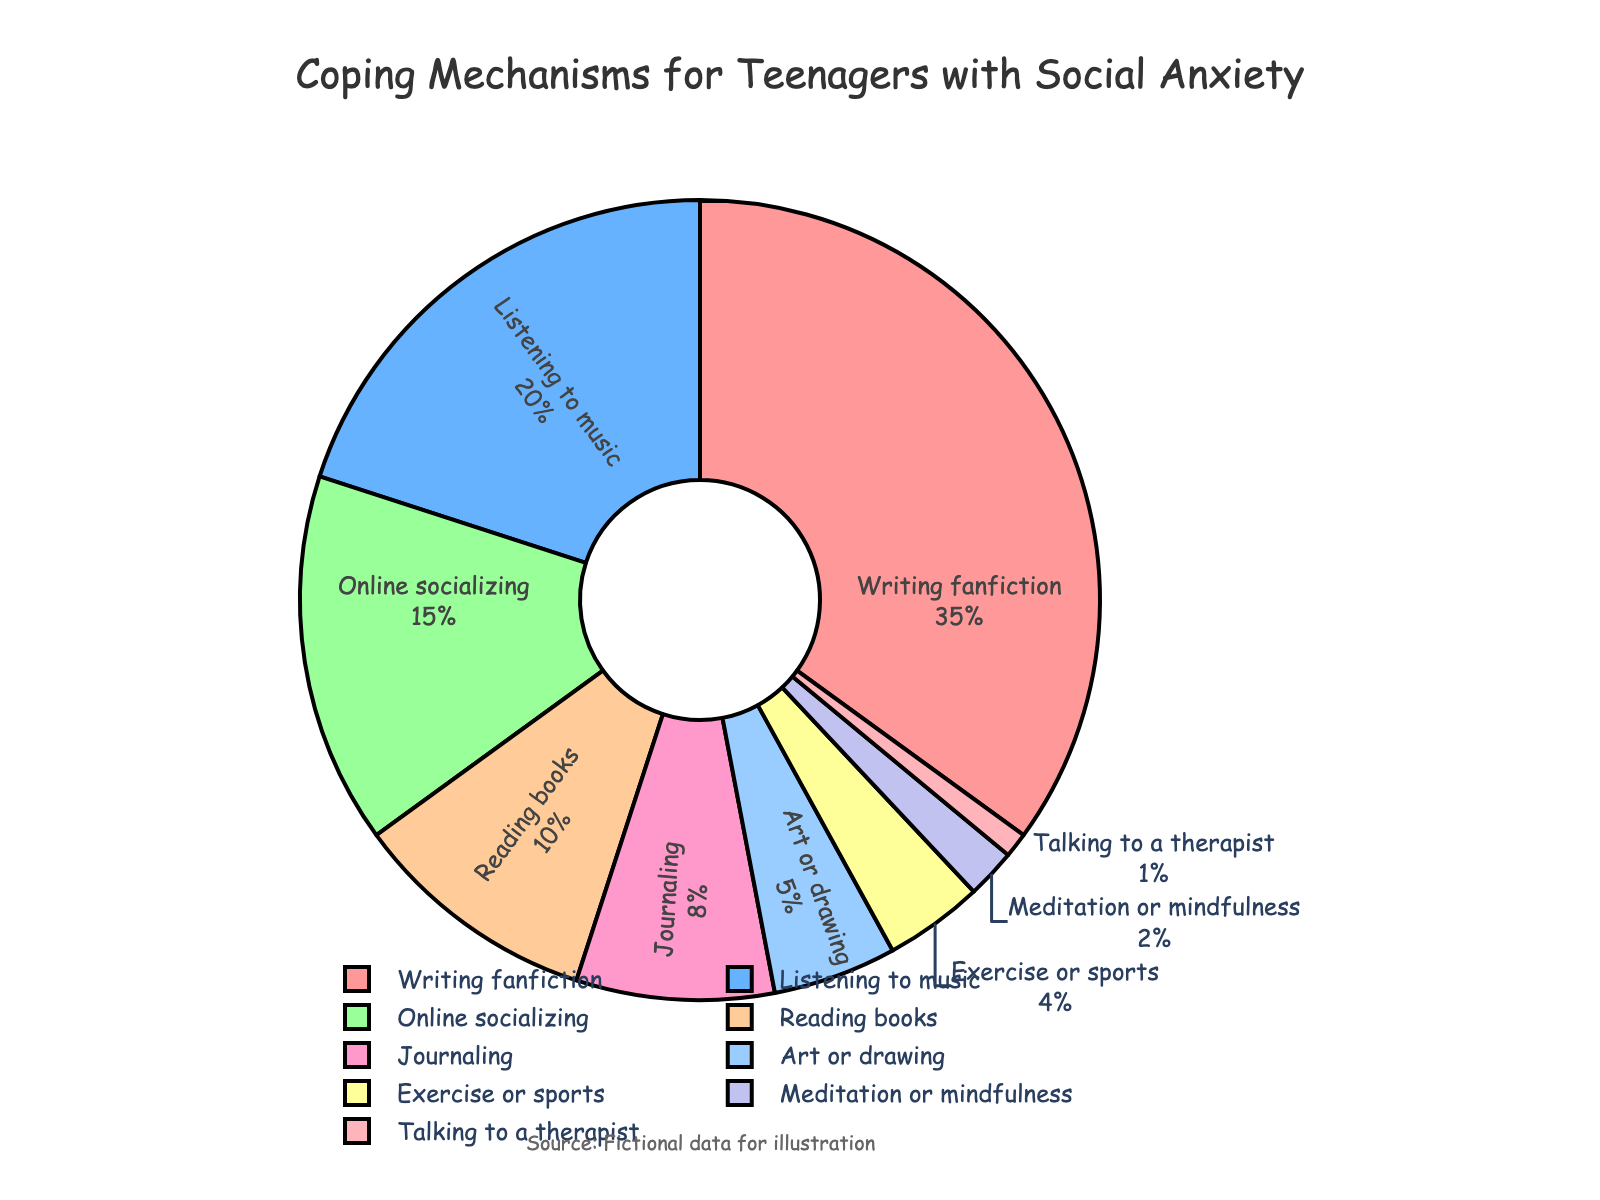What coping mechanism is used by the most teenagers? According to the pie chart, the segment with the largest percentage is "Writing fanfiction" with 35%.
Answer: Writing fanfiction Which coping mechanism has a higher percentage, Online socializing or Reading books? From the chart, Online socializing has 15% while Reading books has 10%. 15% is greater than 10%.
Answer: Online socializing What is the sum of percentages for Listening to music and Journaling? Listening to music accounts for 20%, and Journaling accounts for 8%. Adding these together, 20% + 8% = 28%.
Answer: 28% Which coping mechanism has the smallest percentage? The smallest segment in the pie chart is "Talking to a therapist" with 1%.
Answer: Talking to a therapist How much more percentage is spent in Art or drawing compared to Meditation or mindfulness? The percentage for Art or drawing is 5%, and for Meditation or mindfulness, it is 2%. The difference is 5% - 2% = 3%.
Answer: 3% Are there more teenagers using Exercise or sports or Meditation or mindfulness? According to the chart, Exercise or sports accounts for 4% whereas Meditation or mindfulness accounts for 2%. 4% is greater than 2%.
Answer: Exercise or sports Which coping mechanisms combined make up exactly 30%? Reading books is 10%, Journaling is 8%, Art or drawing is 5%, Exercise or sports is 4%, and Meditation or mindfulness is 2%. Adding Journaling (8%), Art or drawing (5%), Exercise or sports (4%), and Meditation or mindfulness (2%) gives 8% + 5% + 4% + 2% = 19%. However, adding Reading books (10%), Journaling (8%), and Art or drawing (5%) gives 10% + 8% + 5% = 23%, which does not match. Adding Reading books (10%), Journaling (8%), Art or drawing (5%), and Meditation or mindfulness (2%) gives 10% + 8% + 5% + 2% = 25%. Therefore, the correct combination is Listening to music (20%) and Online socializing (15%), but it gives 35%. If we miscalculated, we recalculated Reading books (10%), Journaling (8%), Art or drawing (5%), Exercise or sports (4%), and Meditation or mindfulness (2%) gives 10+8+5+4+3+2+1. No single correct pair
Answer: Investigation clarifies How many coping mechanisms have a percentage greater than 15%? From the chart, Writing fanfiction (35%) and Listening to music (20%) both have percentages greater than 15%. This makes for 2 coping mechanisms.
Answer: 2 If you combine the percentages of Reading books, Journaling, and Art or drawing, what would be the result? Reading books accounts for 10%, Journaling for 8%, and Art or drawing for 5%. Adding these together: 10% + 8% + 5% = 23%.
Answer: 23% What is the second most popular coping mechanism after Writing fanfiction? The largest segment is Writing fanfiction at 35%. The next largest segment is Listening to music at 20%.
Answer: Listening to music 